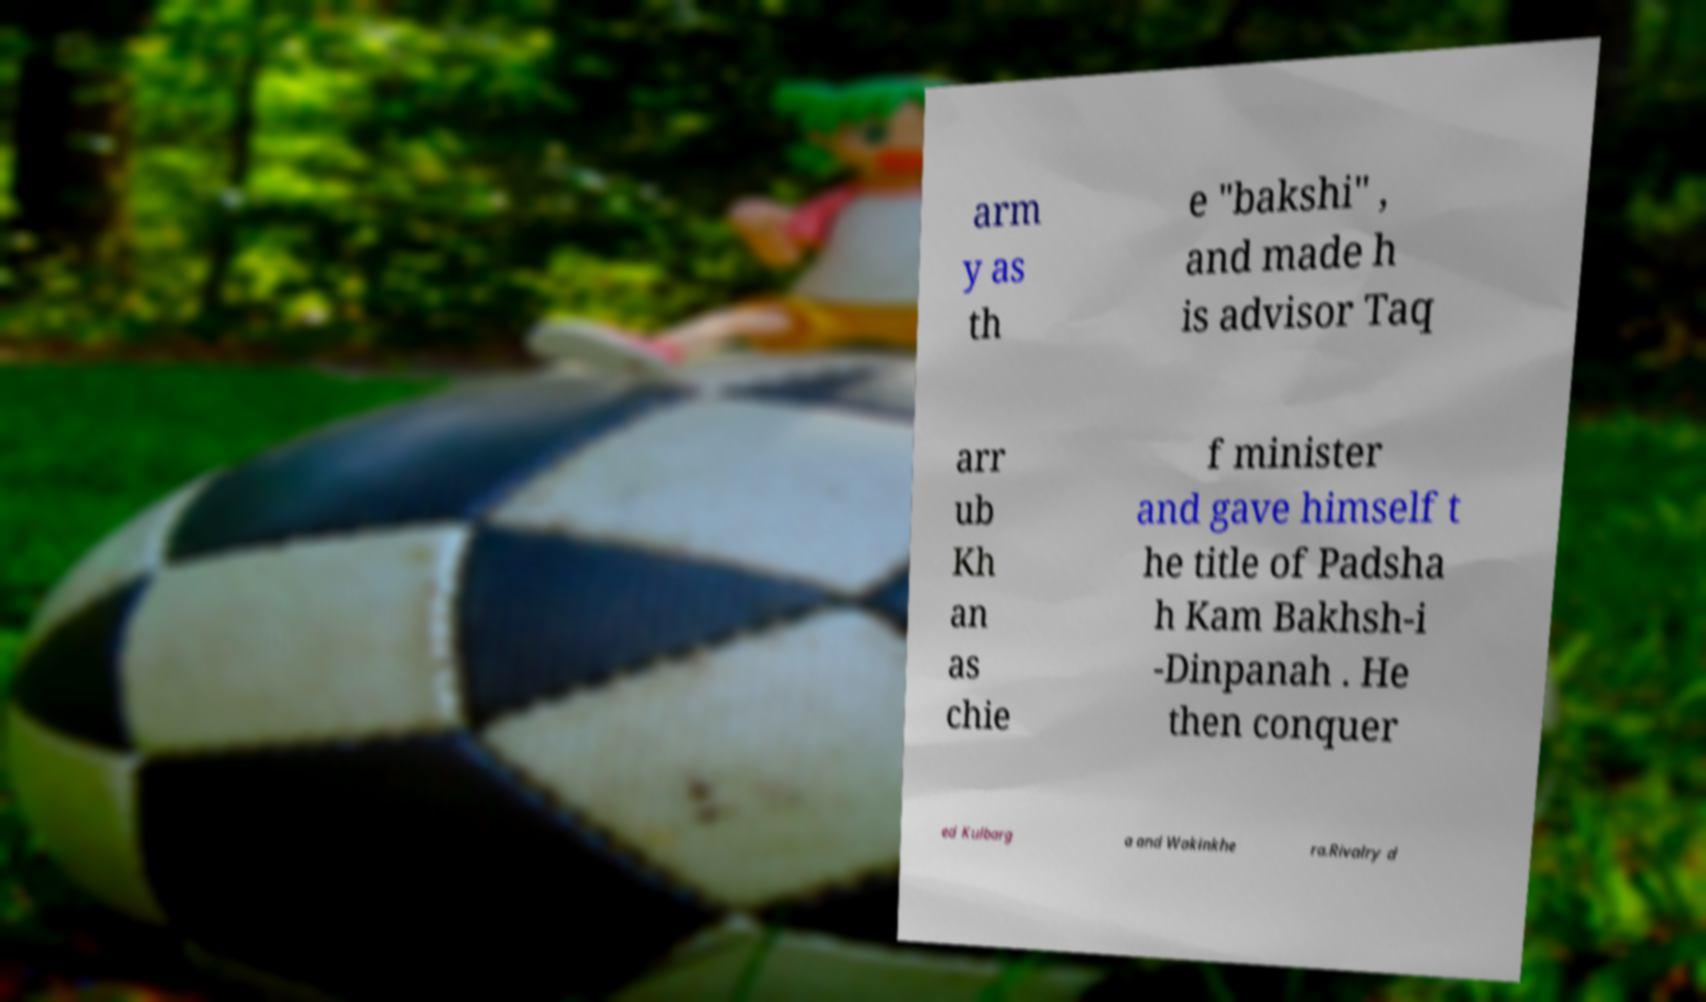Can you accurately transcribe the text from the provided image for me? arm y as th e "bakshi" , and made h is advisor Taq arr ub Kh an as chie f minister and gave himself t he title of Padsha h Kam Bakhsh-i -Dinpanah . He then conquer ed Kulbarg a and Wakinkhe ra.Rivalry d 